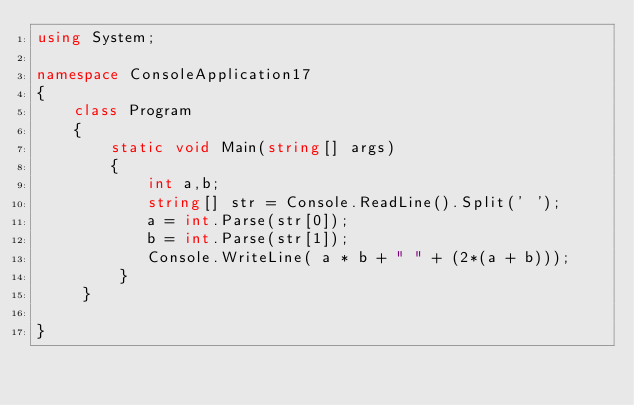Convert code to text. <code><loc_0><loc_0><loc_500><loc_500><_C#_>using System;

namespace ConsoleApplication17
{
    class Program
    {
        static void Main(string[] args)
        {
            int a,b; 
            string[] str = Console.ReadLine().Split(' '); 
            a = int.Parse(str[0]);
            b = int.Parse(str[1]); 
            Console.WriteLine( a * b + " " + (2*(a + b)));
         }
     }
    
}</code> 